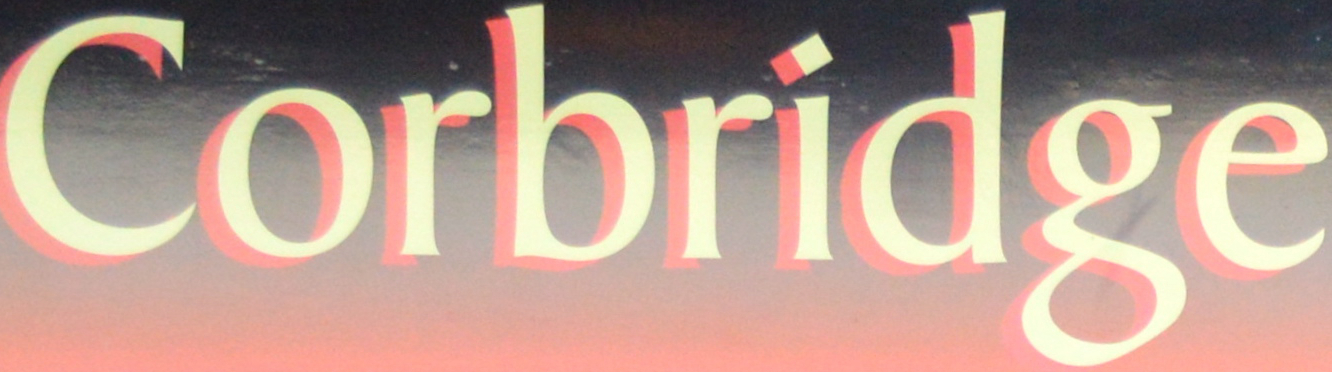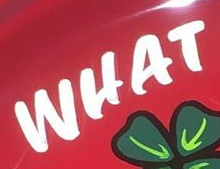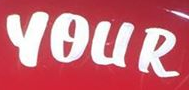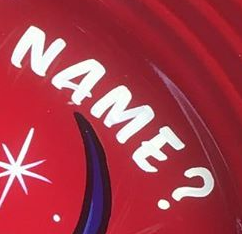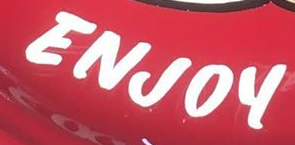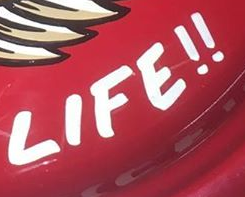Read the text content from these images in order, separated by a semicolon. Corbridge; WHAT; YOUR; NAME?; ENJOY; LIFE!! 